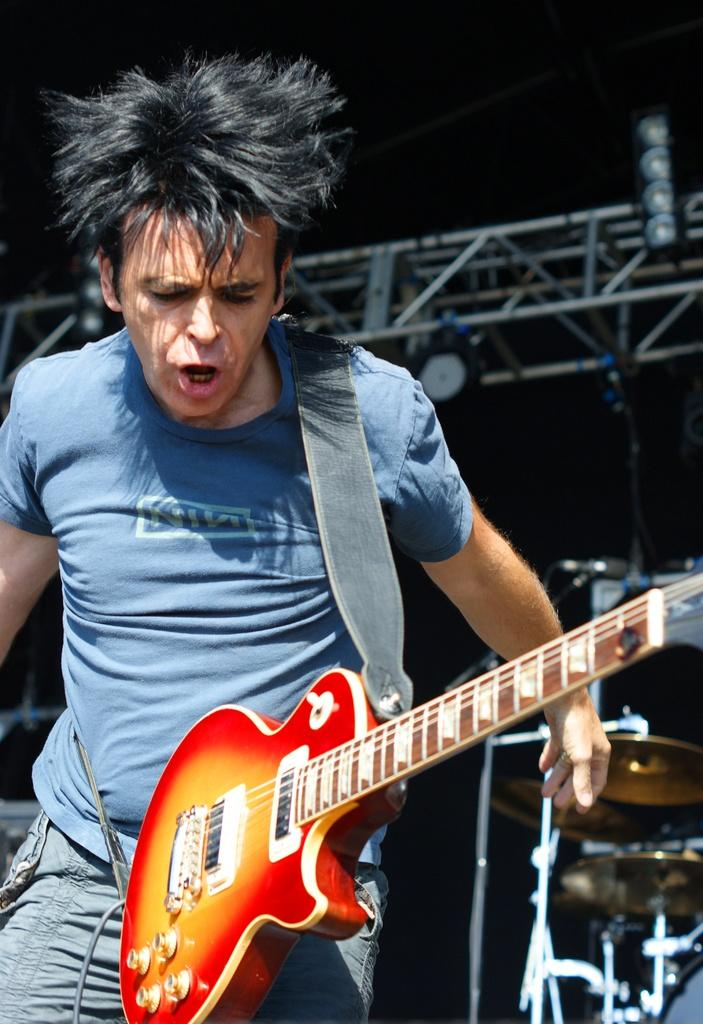What is the man in the image doing? The man is singing a song. What instrument is the man holding in the image? The man is holding a guitar. How is the man producing sound while singing the song? The man is using his mouth to sing the song. What type of clothing is the man wearing on his upper body? The man is wearing a T-shirt. What type of toothpaste is the man using to sing the song? There is no toothpaste present in the image, and the man is using his mouth to sing the song. 